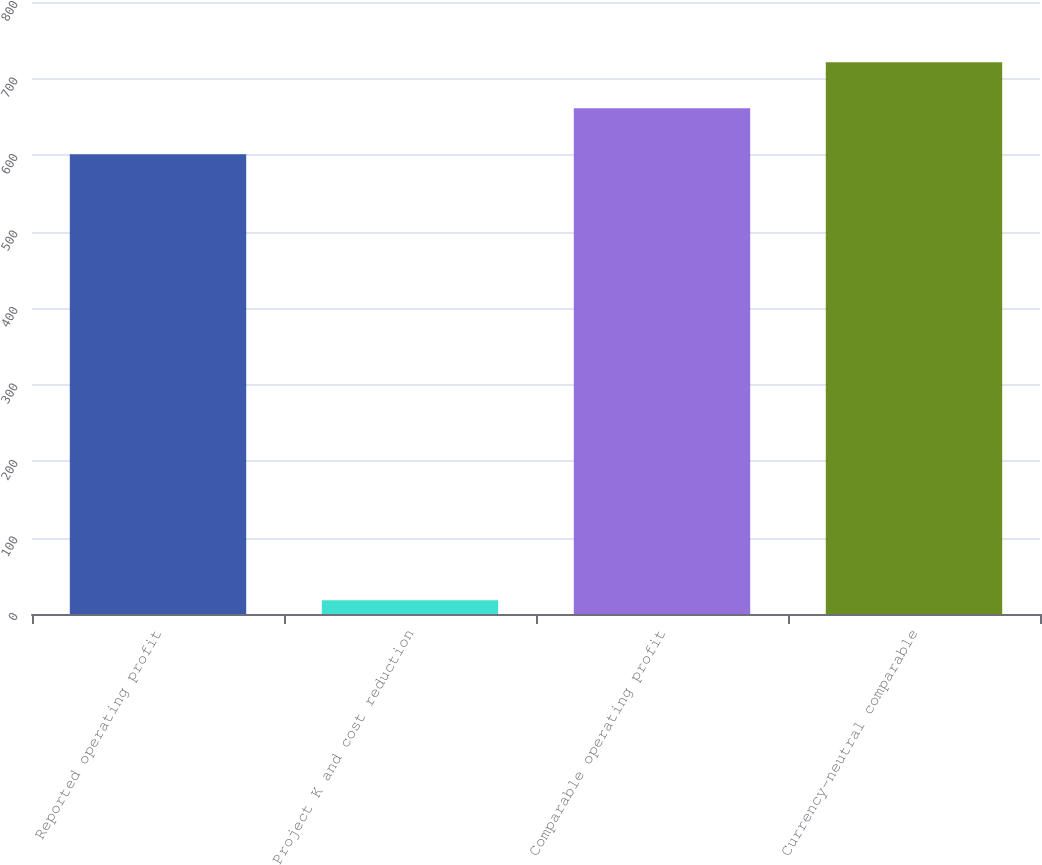Convert chart. <chart><loc_0><loc_0><loc_500><loc_500><bar_chart><fcel>Reported operating profit<fcel>Project K and cost reduction<fcel>Comparable operating profit<fcel>Currency-neutral comparable<nl><fcel>601<fcel>18<fcel>661.1<fcel>721.2<nl></chart> 